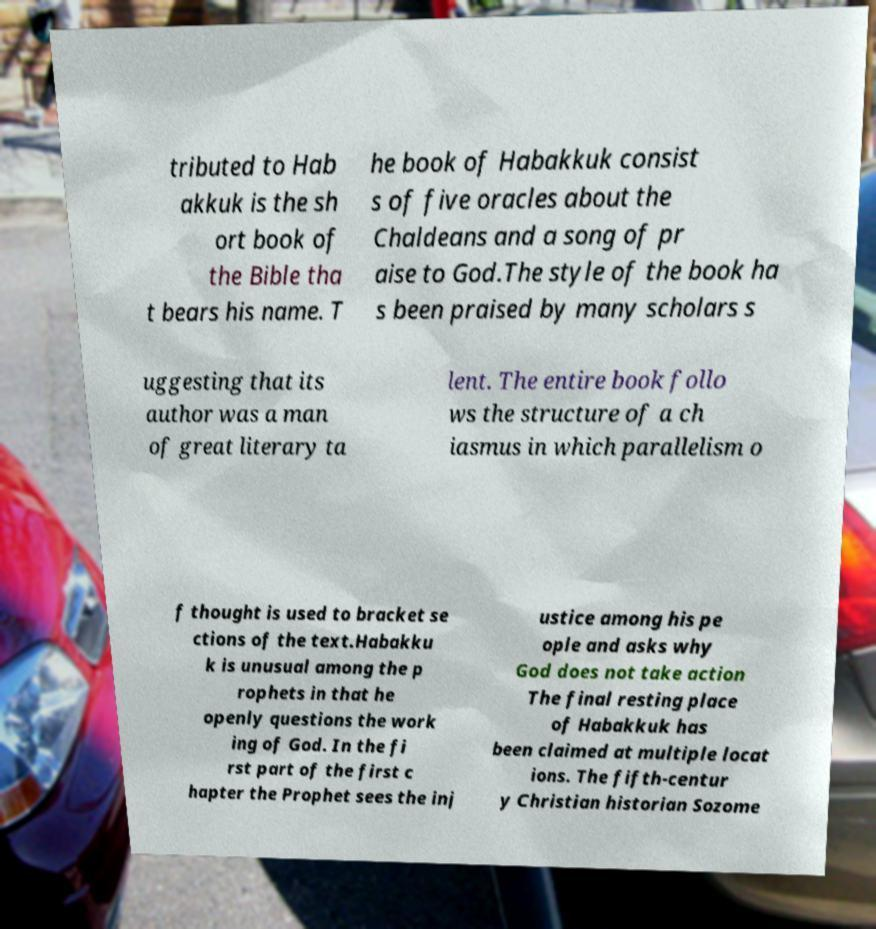Could you extract and type out the text from this image? tributed to Hab akkuk is the sh ort book of the Bible tha t bears his name. T he book of Habakkuk consist s of five oracles about the Chaldeans and a song of pr aise to God.The style of the book ha s been praised by many scholars s uggesting that its author was a man of great literary ta lent. The entire book follo ws the structure of a ch iasmus in which parallelism o f thought is used to bracket se ctions of the text.Habakku k is unusual among the p rophets in that he openly questions the work ing of God. In the fi rst part of the first c hapter the Prophet sees the inj ustice among his pe ople and asks why God does not take action The final resting place of Habakkuk has been claimed at multiple locat ions. The fifth-centur y Christian historian Sozome 